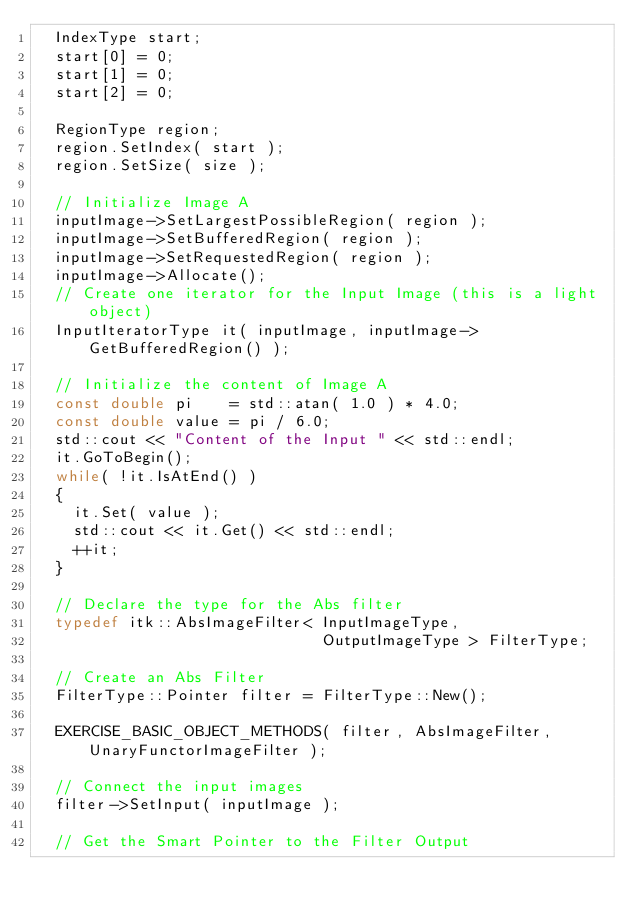Convert code to text. <code><loc_0><loc_0><loc_500><loc_500><_C++_>  IndexType start;
  start[0] = 0;
  start[1] = 0;
  start[2] = 0;

  RegionType region;
  region.SetIndex( start );
  region.SetSize( size );

  // Initialize Image A
  inputImage->SetLargestPossibleRegion( region );
  inputImage->SetBufferedRegion( region );
  inputImage->SetRequestedRegion( region );
  inputImage->Allocate();
  // Create one iterator for the Input Image (this is a light object)
  InputIteratorType it( inputImage, inputImage->GetBufferedRegion() );

  // Initialize the content of Image A
  const double pi    = std::atan( 1.0 ) * 4.0;
  const double value = pi / 6.0;
  std::cout << "Content of the Input " << std::endl;
  it.GoToBegin();
  while( !it.IsAtEnd() )
  {
    it.Set( value );
    std::cout << it.Get() << std::endl;
    ++it;
  }

  // Declare the type for the Abs filter
  typedef itk::AbsImageFilter< InputImageType,
                               OutputImageType > FilterType;

  // Create an Abs Filter
  FilterType::Pointer filter = FilterType::New();

  EXERCISE_BASIC_OBJECT_METHODS( filter, AbsImageFilter, UnaryFunctorImageFilter );

  // Connect the input images
  filter->SetInput( inputImage );

  // Get the Smart Pointer to the Filter Output</code> 